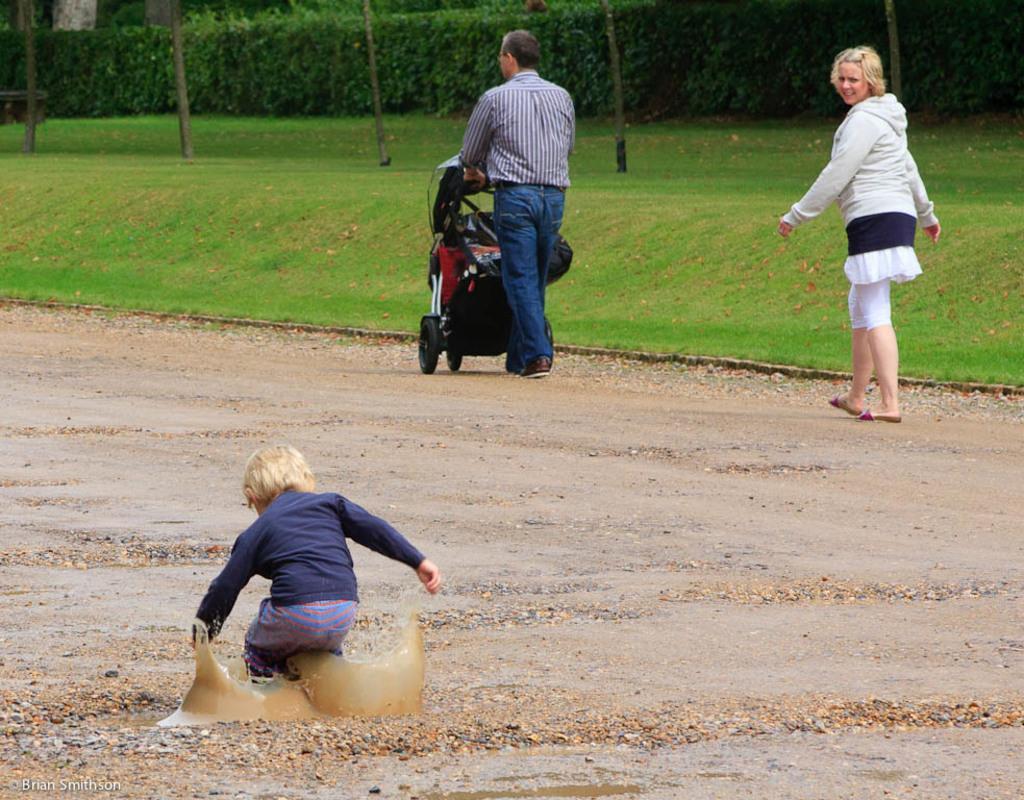In one or two sentences, can you explain what this image depicts? In this image we can see persons on the road. In the background we can see grass, trees and plants. 